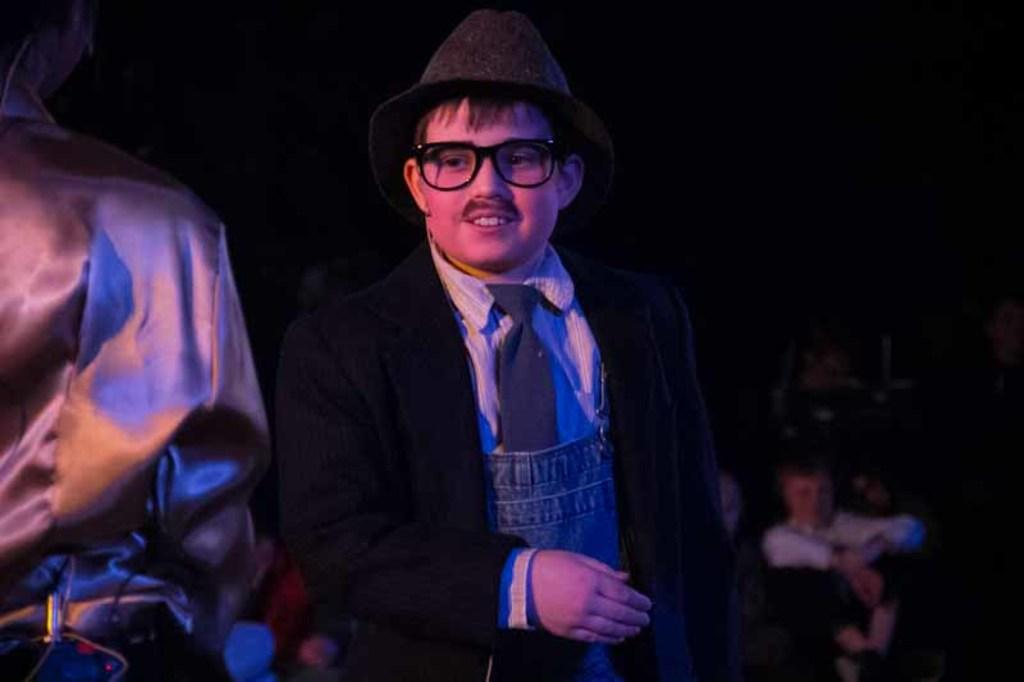Who is the main subject in the image? There is a man in the image. Can you describe the person next to the man? There is a person on the left side of the man. What can be said about the lighting in the image? The background of the image is dark. How many people can be seen in the background? There are few persons visible in the background. What type of clam is being used as a prop in the image? There is no clam present in the image. Can you hear the station in the background of the image? There is no mention of a station or any sound in the image. 